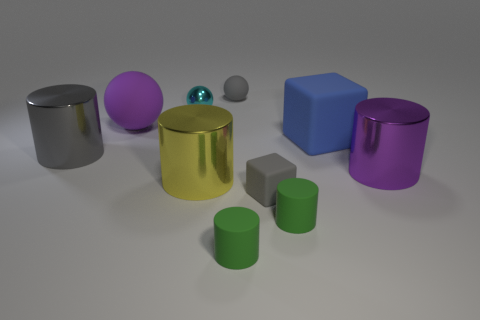Subtract 2 cylinders. How many cylinders are left? 3 Subtract all red cylinders. Subtract all blue cubes. How many cylinders are left? 5 Subtract all spheres. How many objects are left? 7 Add 2 rubber objects. How many rubber objects are left? 8 Add 3 small green shiny objects. How many small green shiny objects exist? 3 Subtract 0 purple cubes. How many objects are left? 10 Subtract all gray things. Subtract all big purple cylinders. How many objects are left? 6 